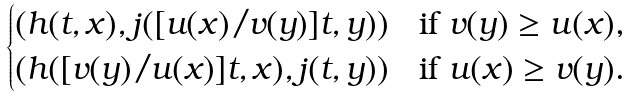<formula> <loc_0><loc_0><loc_500><loc_500>\begin{cases} ( h ( t , x ) , j ( [ u ( x ) / v ( y ) ] t , y ) ) & \text {if $v(y) \geq u(x)$,} \\ ( h ( [ v ( y ) / u ( x ) ] t , x ) , j ( t , y ) ) & \text {if $u(x) \geq v(y)$.} \end{cases}</formula> 